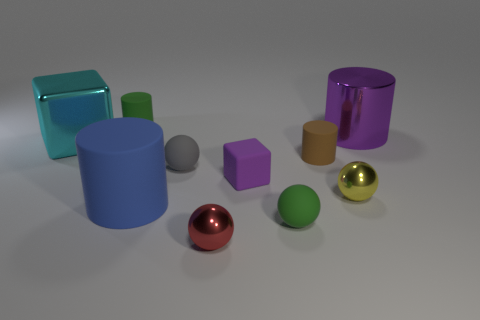Subtract all gray cylinders. Subtract all gray blocks. How many cylinders are left? 4 Subtract all balls. How many objects are left? 6 Subtract all tiny metal things. Subtract all large purple cylinders. How many objects are left? 7 Add 5 red spheres. How many red spheres are left? 6 Add 3 blue matte cylinders. How many blue matte cylinders exist? 4 Subtract 1 cyan blocks. How many objects are left? 9 